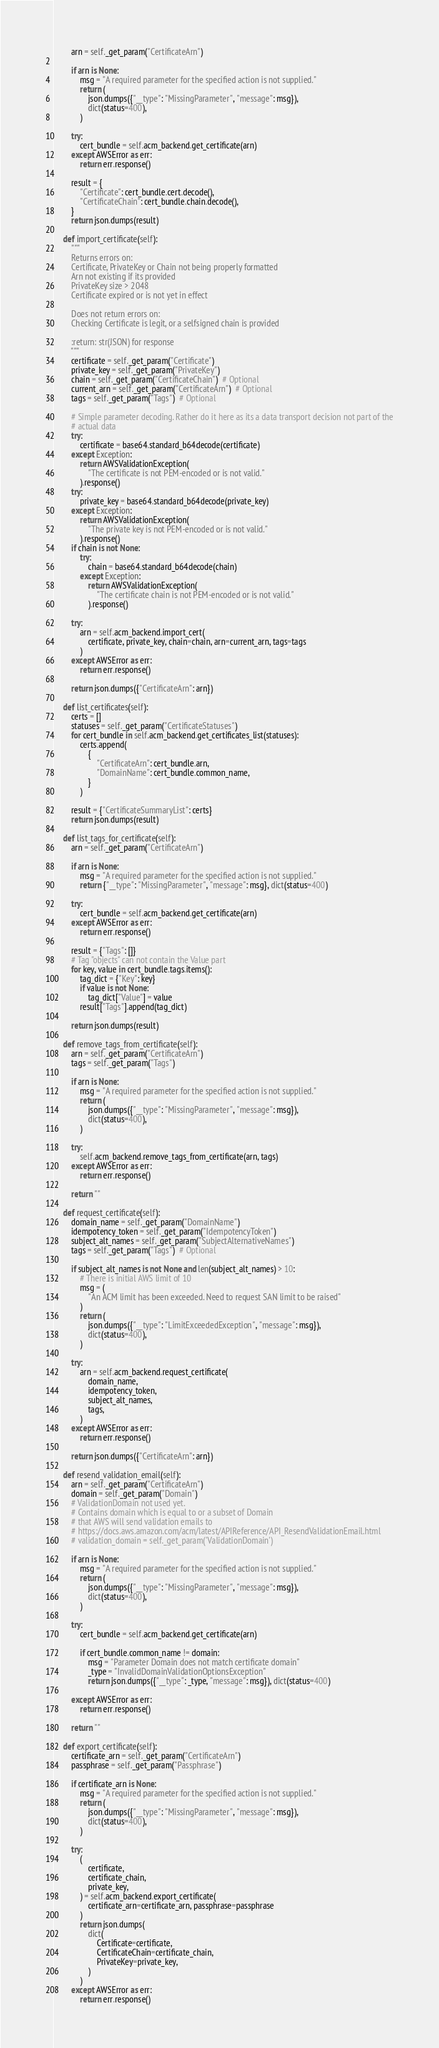<code> <loc_0><loc_0><loc_500><loc_500><_Python_>        arn = self._get_param("CertificateArn")

        if arn is None:
            msg = "A required parameter for the specified action is not supplied."
            return (
                json.dumps({"__type": "MissingParameter", "message": msg}),
                dict(status=400),
            )

        try:
            cert_bundle = self.acm_backend.get_certificate(arn)
        except AWSError as err:
            return err.response()

        result = {
            "Certificate": cert_bundle.cert.decode(),
            "CertificateChain": cert_bundle.chain.decode(),
        }
        return json.dumps(result)

    def import_certificate(self):
        """
        Returns errors on:
        Certificate, PrivateKey or Chain not being properly formatted
        Arn not existing if its provided
        PrivateKey size > 2048
        Certificate expired or is not yet in effect

        Does not return errors on:
        Checking Certificate is legit, or a selfsigned chain is provided

        :return: str(JSON) for response
        """
        certificate = self._get_param("Certificate")
        private_key = self._get_param("PrivateKey")
        chain = self._get_param("CertificateChain")  # Optional
        current_arn = self._get_param("CertificateArn")  # Optional
        tags = self._get_param("Tags")  # Optional

        # Simple parameter decoding. Rather do it here as its a data transport decision not part of the
        # actual data
        try:
            certificate = base64.standard_b64decode(certificate)
        except Exception:
            return AWSValidationException(
                "The certificate is not PEM-encoded or is not valid."
            ).response()
        try:
            private_key = base64.standard_b64decode(private_key)
        except Exception:
            return AWSValidationException(
                "The private key is not PEM-encoded or is not valid."
            ).response()
        if chain is not None:
            try:
                chain = base64.standard_b64decode(chain)
            except Exception:
                return AWSValidationException(
                    "The certificate chain is not PEM-encoded or is not valid."
                ).response()

        try:
            arn = self.acm_backend.import_cert(
                certificate, private_key, chain=chain, arn=current_arn, tags=tags
            )
        except AWSError as err:
            return err.response()

        return json.dumps({"CertificateArn": arn})

    def list_certificates(self):
        certs = []
        statuses = self._get_param("CertificateStatuses")
        for cert_bundle in self.acm_backend.get_certificates_list(statuses):
            certs.append(
                {
                    "CertificateArn": cert_bundle.arn,
                    "DomainName": cert_bundle.common_name,
                }
            )

        result = {"CertificateSummaryList": certs}
        return json.dumps(result)

    def list_tags_for_certificate(self):
        arn = self._get_param("CertificateArn")

        if arn is None:
            msg = "A required parameter for the specified action is not supplied."
            return {"__type": "MissingParameter", "message": msg}, dict(status=400)

        try:
            cert_bundle = self.acm_backend.get_certificate(arn)
        except AWSError as err:
            return err.response()

        result = {"Tags": []}
        # Tag "objects" can not contain the Value part
        for key, value in cert_bundle.tags.items():
            tag_dict = {"Key": key}
            if value is not None:
                tag_dict["Value"] = value
            result["Tags"].append(tag_dict)

        return json.dumps(result)

    def remove_tags_from_certificate(self):
        arn = self._get_param("CertificateArn")
        tags = self._get_param("Tags")

        if arn is None:
            msg = "A required parameter for the specified action is not supplied."
            return (
                json.dumps({"__type": "MissingParameter", "message": msg}),
                dict(status=400),
            )

        try:
            self.acm_backend.remove_tags_from_certificate(arn, tags)
        except AWSError as err:
            return err.response()

        return ""

    def request_certificate(self):
        domain_name = self._get_param("DomainName")
        idempotency_token = self._get_param("IdempotencyToken")
        subject_alt_names = self._get_param("SubjectAlternativeNames")
        tags = self._get_param("Tags")  # Optional

        if subject_alt_names is not None and len(subject_alt_names) > 10:
            # There is initial AWS limit of 10
            msg = (
                "An ACM limit has been exceeded. Need to request SAN limit to be raised"
            )
            return (
                json.dumps({"__type": "LimitExceededException", "message": msg}),
                dict(status=400),
            )

        try:
            arn = self.acm_backend.request_certificate(
                domain_name,
                idempotency_token,
                subject_alt_names,
                tags,
            )
        except AWSError as err:
            return err.response()

        return json.dumps({"CertificateArn": arn})

    def resend_validation_email(self):
        arn = self._get_param("CertificateArn")
        domain = self._get_param("Domain")
        # ValidationDomain not used yet.
        # Contains domain which is equal to or a subset of Domain
        # that AWS will send validation emails to
        # https://docs.aws.amazon.com/acm/latest/APIReference/API_ResendValidationEmail.html
        # validation_domain = self._get_param('ValidationDomain')

        if arn is None:
            msg = "A required parameter for the specified action is not supplied."
            return (
                json.dumps({"__type": "MissingParameter", "message": msg}),
                dict(status=400),
            )

        try:
            cert_bundle = self.acm_backend.get_certificate(arn)

            if cert_bundle.common_name != domain:
                msg = "Parameter Domain does not match certificate domain"
                _type = "InvalidDomainValidationOptionsException"
                return json.dumps({"__type": _type, "message": msg}), dict(status=400)

        except AWSError as err:
            return err.response()

        return ""

    def export_certificate(self):
        certificate_arn = self._get_param("CertificateArn")
        passphrase = self._get_param("Passphrase")

        if certificate_arn is None:
            msg = "A required parameter for the specified action is not supplied."
            return (
                json.dumps({"__type": "MissingParameter", "message": msg}),
                dict(status=400),
            )

        try:
            (
                certificate,
                certificate_chain,
                private_key,
            ) = self.acm_backend.export_certificate(
                certificate_arn=certificate_arn, passphrase=passphrase
            )
            return json.dumps(
                dict(
                    Certificate=certificate,
                    CertificateChain=certificate_chain,
                    PrivateKey=private_key,
                )
            )
        except AWSError as err:
            return err.response()
</code> 